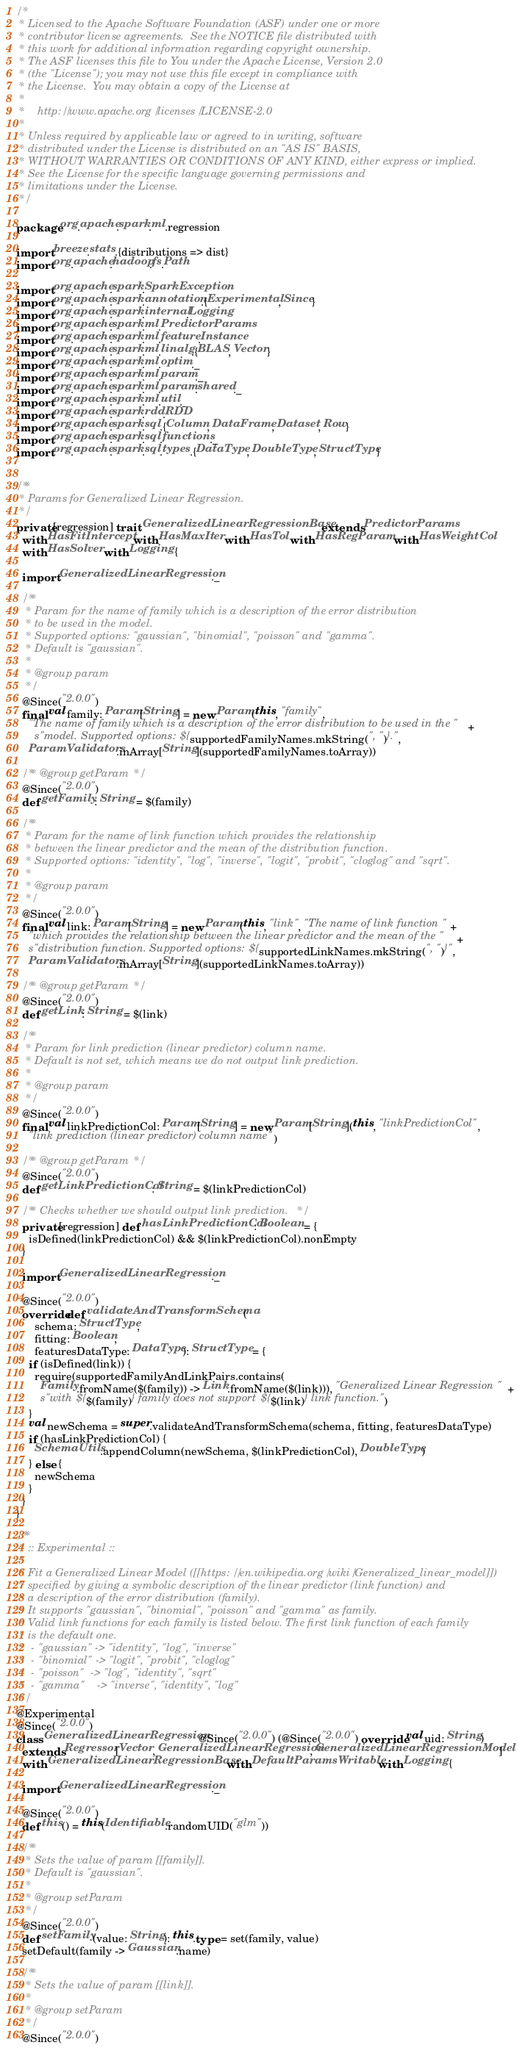<code> <loc_0><loc_0><loc_500><loc_500><_Scala_>/*
 * Licensed to the Apache Software Foundation (ASF) under one or more
 * contributor license agreements.  See the NOTICE file distributed with
 * this work for additional information regarding copyright ownership.
 * The ASF licenses this file to You under the Apache License, Version 2.0
 * (the "License"); you may not use this file except in compliance with
 * the License.  You may obtain a copy of the License at
 *
 *    http://www.apache.org/licenses/LICENSE-2.0
 *
 * Unless required by applicable law or agreed to in writing, software
 * distributed under the License is distributed on an "AS IS" BASIS,
 * WITHOUT WARRANTIES OR CONDITIONS OF ANY KIND, either express or implied.
 * See the License for the specific language governing permissions and
 * limitations under the License.
 */

package org.apache.spark.ml.regression

import breeze.stats.{distributions => dist}
import org.apache.hadoop.fs.Path

import org.apache.spark.SparkException
import org.apache.spark.annotation.{Experimental, Since}
import org.apache.spark.internal.Logging
import org.apache.spark.ml.PredictorParams
import org.apache.spark.ml.feature.Instance
import org.apache.spark.ml.linalg.{BLAS, Vector}
import org.apache.spark.ml.optim._
import org.apache.spark.ml.param._
import org.apache.spark.ml.param.shared._
import org.apache.spark.ml.util._
import org.apache.spark.rdd.RDD
import org.apache.spark.sql.{Column, DataFrame, Dataset, Row}
import org.apache.spark.sql.functions._
import org.apache.spark.sql.types.{DataType, DoubleType, StructType}


/**
 * Params for Generalized Linear Regression.
 */
private[regression] trait GeneralizedLinearRegressionBase extends PredictorParams
  with HasFitIntercept with HasMaxIter with HasTol with HasRegParam with HasWeightCol
  with HasSolver with Logging {

  import GeneralizedLinearRegression._

  /**
   * Param for the name of family which is a description of the error distribution
   * to be used in the model.
   * Supported options: "gaussian", "binomial", "poisson" and "gamma".
   * Default is "gaussian".
   *
   * @group param
   */
  @Since("2.0.0")
  final val family: Param[String] = new Param(this, "family",
    "The name of family which is a description of the error distribution to be used in the " +
      s"model. Supported options: ${supportedFamilyNames.mkString(", ")}.",
    ParamValidators.inArray[String](supportedFamilyNames.toArray))

  /** @group getParam */
  @Since("2.0.0")
  def getFamily: String = $(family)

  /**
   * Param for the name of link function which provides the relationship
   * between the linear predictor and the mean of the distribution function.
   * Supported options: "identity", "log", "inverse", "logit", "probit", "cloglog" and "sqrt".
   *
   * @group param
   */
  @Since("2.0.0")
  final val link: Param[String] = new Param(this, "link", "The name of link function " +
    "which provides the relationship between the linear predictor and the mean of the " +
    s"distribution function. Supported options: ${supportedLinkNames.mkString(", ")}",
    ParamValidators.inArray[String](supportedLinkNames.toArray))

  /** @group getParam */
  @Since("2.0.0")
  def getLink: String = $(link)

  /**
   * Param for link prediction (linear predictor) column name.
   * Default is not set, which means we do not output link prediction.
   *
   * @group param
   */
  @Since("2.0.0")
  final val linkPredictionCol: Param[String] = new Param[String](this, "linkPredictionCol",
    "link prediction (linear predictor) column name")

  /** @group getParam */
  @Since("2.0.0")
  def getLinkPredictionCol: String = $(linkPredictionCol)

  /** Checks whether we should output link prediction. */
  private[regression] def hasLinkPredictionCol: Boolean = {
    isDefined(linkPredictionCol) && $(linkPredictionCol).nonEmpty
  }

  import GeneralizedLinearRegression._

  @Since("2.0.0")
  override def validateAndTransformSchema(
      schema: StructType,
      fitting: Boolean,
      featuresDataType: DataType): StructType = {
    if (isDefined(link)) {
      require(supportedFamilyAndLinkPairs.contains(
        Family.fromName($(family)) -> Link.fromName($(link))), "Generalized Linear Regression " +
        s"with ${$(family)} family does not support ${$(link)} link function.")
    }
    val newSchema = super.validateAndTransformSchema(schema, fitting, featuresDataType)
    if (hasLinkPredictionCol) {
      SchemaUtils.appendColumn(newSchema, $(linkPredictionCol), DoubleType)
    } else {
      newSchema
    }
  }
}

/**
 * :: Experimental ::
 *
 * Fit a Generalized Linear Model ([[https://en.wikipedia.org/wiki/Generalized_linear_model]])
 * specified by giving a symbolic description of the linear predictor (link function) and
 * a description of the error distribution (family).
 * It supports "gaussian", "binomial", "poisson" and "gamma" as family.
 * Valid link functions for each family is listed below. The first link function of each family
 * is the default one.
 *  - "gaussian" -> "identity", "log", "inverse"
 *  - "binomial" -> "logit", "probit", "cloglog"
 *  - "poisson"  -> "log", "identity", "sqrt"
 *  - "gamma"    -> "inverse", "identity", "log"
 */
@Experimental
@Since("2.0.0")
class GeneralizedLinearRegression @Since("2.0.0") (@Since("2.0.0") override val uid: String)
  extends Regressor[Vector, GeneralizedLinearRegression, GeneralizedLinearRegressionModel]
  with GeneralizedLinearRegressionBase with DefaultParamsWritable with Logging {

  import GeneralizedLinearRegression._

  @Since("2.0.0")
  def this() = this(Identifiable.randomUID("glm"))

  /**
   * Sets the value of param [[family]].
   * Default is "gaussian".
   *
   * @group setParam
   */
  @Since("2.0.0")
  def setFamily(value: String): this.type = set(family, value)
  setDefault(family -> Gaussian.name)

  /**
   * Sets the value of param [[link]].
   *
   * @group setParam
   */
  @Since("2.0.0")</code> 